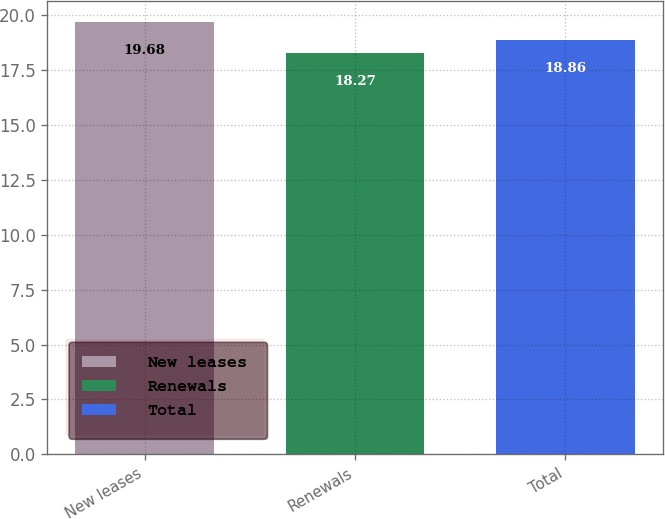Convert chart to OTSL. <chart><loc_0><loc_0><loc_500><loc_500><bar_chart><fcel>New leases<fcel>Renewals<fcel>Total<nl><fcel>19.68<fcel>18.27<fcel>18.86<nl></chart> 